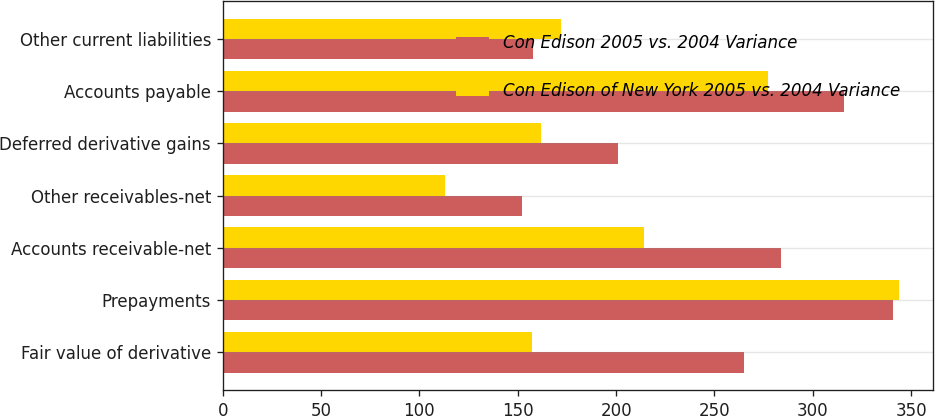Convert chart to OTSL. <chart><loc_0><loc_0><loc_500><loc_500><stacked_bar_chart><ecel><fcel>Fair value of derivative<fcel>Prepayments<fcel>Accounts receivable-net<fcel>Other receivables-net<fcel>Deferred derivative gains<fcel>Accounts payable<fcel>Other current liabilities<nl><fcel>Con Edison 2005 vs. 2004 Variance<fcel>265<fcel>341<fcel>284<fcel>152<fcel>201<fcel>316<fcel>158<nl><fcel>Con Edison of New York 2005 vs. 2004 Variance<fcel>157<fcel>344<fcel>214<fcel>113<fcel>162<fcel>277<fcel>172<nl></chart> 